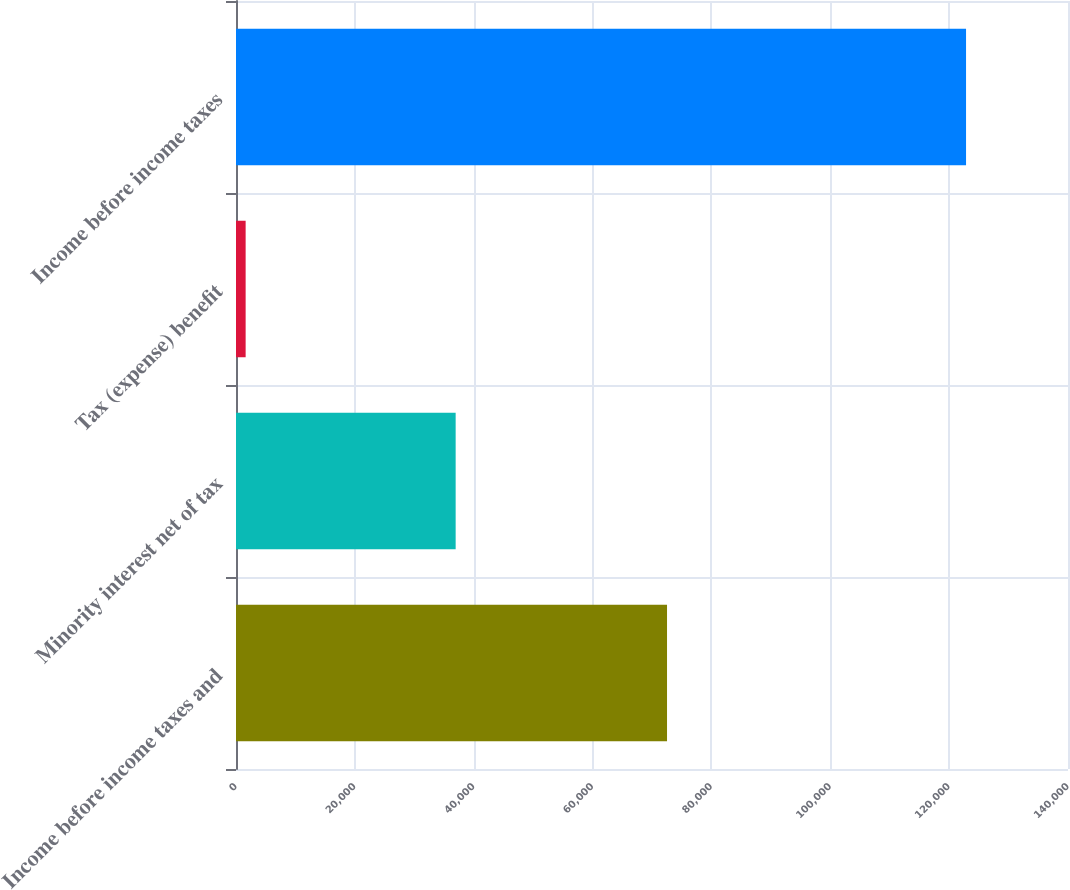Convert chart to OTSL. <chart><loc_0><loc_0><loc_500><loc_500><bar_chart><fcel>Income before income taxes and<fcel>Minority interest net of tax<fcel>Tax (expense) benefit<fcel>Income before income taxes<nl><fcel>72529<fcel>36961<fcel>1622<fcel>122844<nl></chart> 